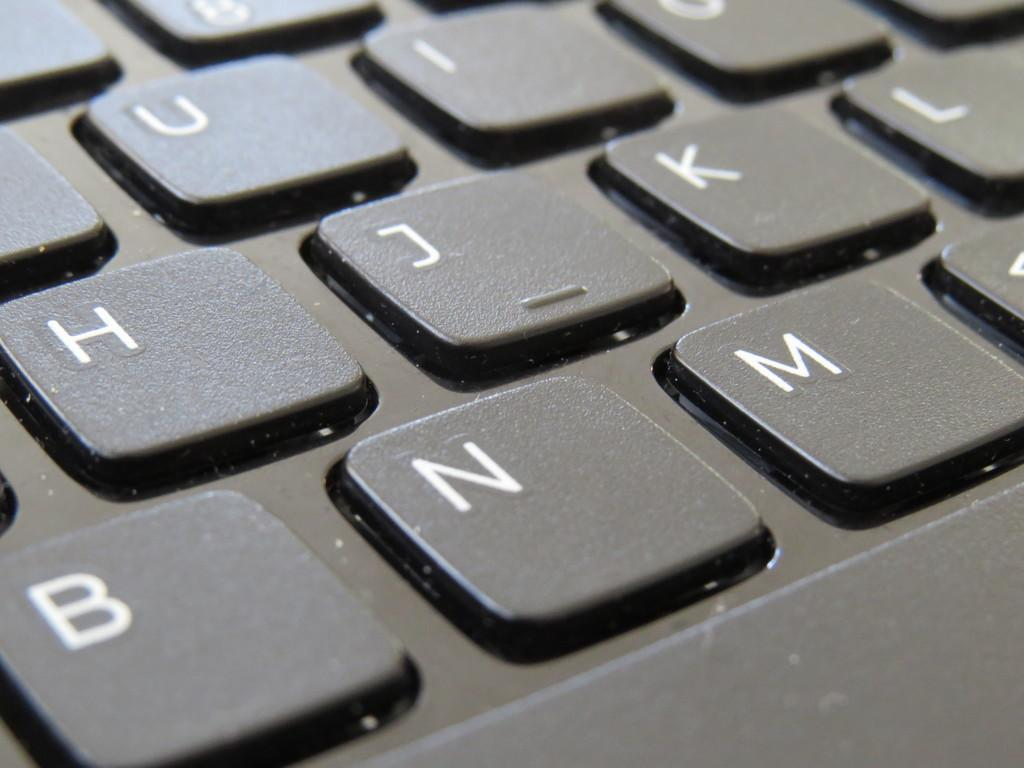<image>
Create a compact narrative representing the image presented. A close up look at the U, I, H, J, K, B, N, and M keys on a black keyboard. 